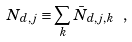<formula> <loc_0><loc_0><loc_500><loc_500>N _ { d , j } \equiv \sum _ { k } \bar { N } _ { d , j , k } \ ,</formula> 